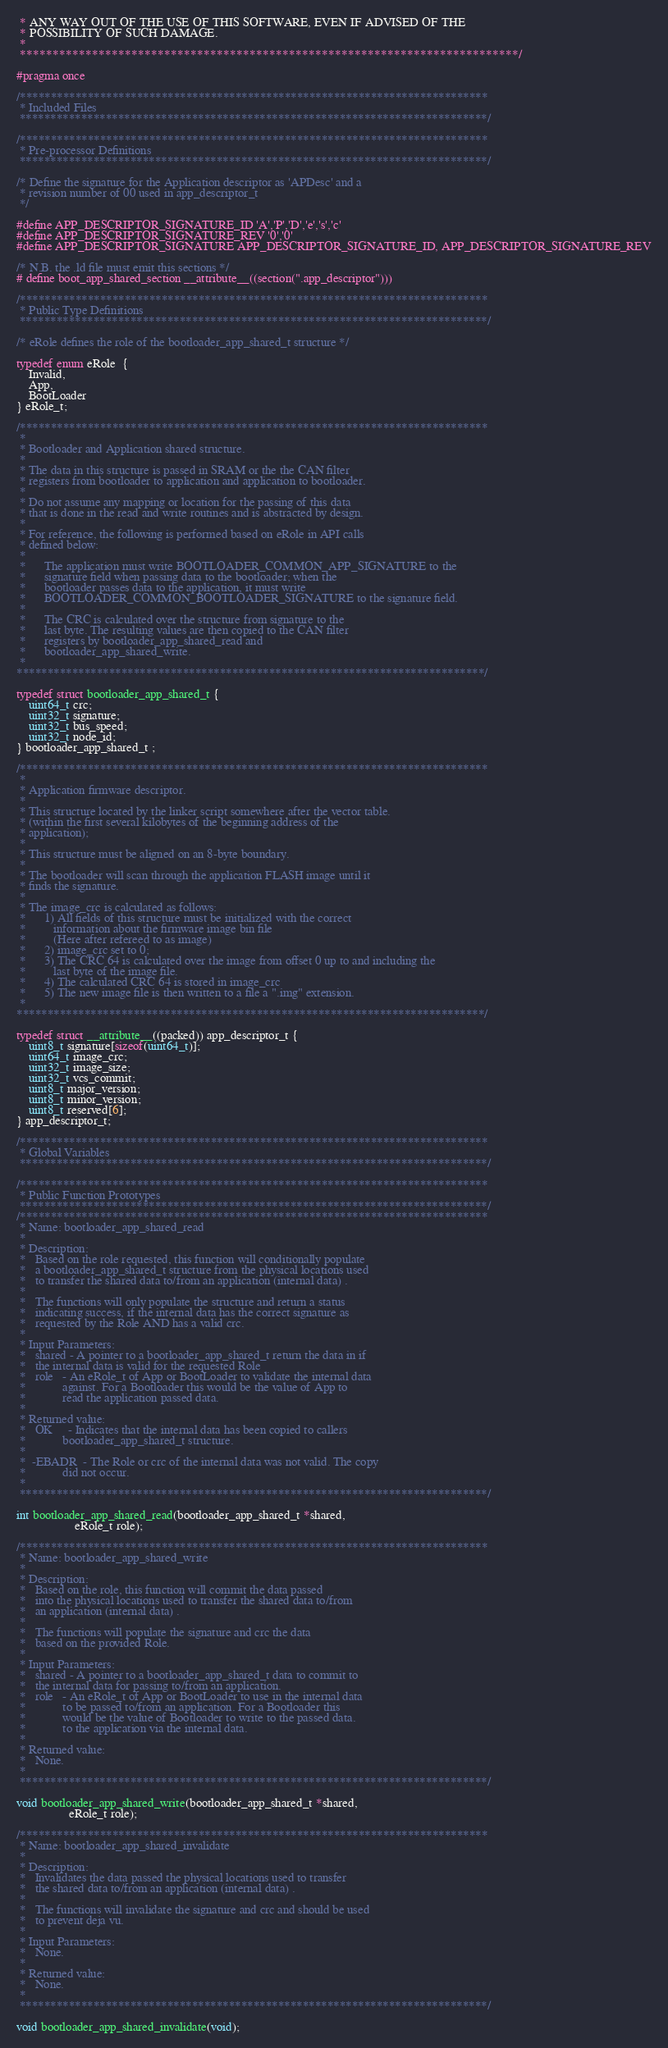<code> <loc_0><loc_0><loc_500><loc_500><_C_> * ANY WAY OUT OF THE USE OF THIS SOFTWARE, EVEN IF ADVISED OF THE
 * POSSIBILITY OF SUCH DAMAGE.
 *
 ****************************************************************************/

#pragma once

/****************************************************************************
 * Included Files
 ****************************************************************************/

/****************************************************************************
 * Pre-processor Definitions
 ****************************************************************************/

/* Define the signature for the Application descriptor as 'APDesc' and a
 * revision number of 00 used in app_descriptor_t
 */

#define APP_DESCRIPTOR_SIGNATURE_ID 'A','P','D','e','s','c'
#define APP_DESCRIPTOR_SIGNATURE_REV '0','0'
#define APP_DESCRIPTOR_SIGNATURE APP_DESCRIPTOR_SIGNATURE_ID, APP_DESCRIPTOR_SIGNATURE_REV

/* N.B. the .ld file must emit this sections */
# define boot_app_shared_section __attribute__((section(".app_descriptor")))

/****************************************************************************
 * Public Type Definitions
 ****************************************************************************/

/* eRole defines the role of the bootloader_app_shared_t structure */

typedef enum eRole  {
	Invalid,
	App,
	BootLoader
} eRole_t;

/****************************************************************************
 *
 * Bootloader and Application shared structure.
 *
 * The data in this structure is passed in SRAM or the the CAN filter
 * registers from bootloader to application and application to bootloader.
 *
 * Do not assume any mapping or location for the passing of this data
 * that is done in the read and write routines and is abstracted by design.
 *
 * For reference, the following is performed based on eRole in API calls
 * defined below:
 *
 *      The application must write BOOTLOADER_COMMON_APP_SIGNATURE to the
 *      signature field when passing data to the bootloader; when the
 *      bootloader passes data to the application, it must write
 *      BOOTLOADER_COMMON_BOOTLOADER_SIGNATURE to the signature field.
 *
 *      The CRC is calculated over the structure from signature to the
 *      last byte. The resulting values are then copied to the CAN filter
 *      registers by bootloader_app_shared_read and
 *      bootloader_app_shared_write.
 *
****************************************************************************/

typedef struct bootloader_app_shared_t {
	uint64_t crc;
	uint32_t signature;
	uint32_t bus_speed;
	uint32_t node_id;
} bootloader_app_shared_t ;

/****************************************************************************
 *
 * Application firmware descriptor.
 *
 * This structure located by the linker script somewhere after the vector table.
 * (within the first several kilobytes of the beginning address of the
 * application);
 *
 * This structure must be aligned on an 8-byte boundary.
 *
 * The bootloader will scan through the application FLASH image until it
 * finds the signature.
 *
 * The image_crc is calculated as follows:
 *      1) All fields of this structure must be initialized with the correct
 *         information about the firmware image bin file
 *         (Here after refereed to as image)
 *      2) image_crc set to 0;
 *      3) The CRC 64 is calculated over the image from offset 0 up to and including the
 *         last byte of the image file.
 *      4) The calculated CRC 64 is stored in image_crc
 *      5) The new image file is then written to a file a ".img" extension.
 *
****************************************************************************/

typedef struct __attribute__((packed)) app_descriptor_t {
	uint8_t signature[sizeof(uint64_t)];
	uint64_t image_crc;
	uint32_t image_size;
	uint32_t vcs_commit;
	uint8_t major_version;
	uint8_t minor_version;
	uint8_t reserved[6];
} app_descriptor_t;

/****************************************************************************
 * Global Variables
 ****************************************************************************/

/****************************************************************************
 * Public Function Prototypes
 ****************************************************************************/
/****************************************************************************
 * Name: bootloader_app_shared_read
 *
 * Description:
 *   Based on the role requested, this function will conditionally populate
 *   a bootloader_app_shared_t structure from the physical locations used
 *   to transfer the shared data to/from an application (internal data) .
 *
 *   The functions will only populate the structure and return a status
 *   indicating success, if the internal data has the correct signature as
 *   requested by the Role AND has a valid crc.
 *
 * Input Parameters:
 *   shared - A pointer to a bootloader_app_shared_t return the data in if
 *   the internal data is valid for the requested Role
 *   role   - An eRole_t of App or BootLoader to validate the internal data
 *            against. For a Bootloader this would be the value of App to
 *            read the application passed data.
 *
 * Returned value:
 *   OK     - Indicates that the internal data has been copied to callers
 *            bootloader_app_shared_t structure.
 *
 *  -EBADR  - The Role or crc of the internal data was not valid. The copy
 *            did not occur.
 *
 ****************************************************************************/

int bootloader_app_shared_read(bootloader_app_shared_t *shared,
			       eRole_t role);

/****************************************************************************
 * Name: bootloader_app_shared_write
 *
 * Description:
 *   Based on the role, this function will commit the data passed
 *   into the physical locations used to transfer the shared data to/from
 *   an application (internal data) .
 *
 *   The functions will populate the signature and crc the data
 *   based on the provided Role.
 *
 * Input Parameters:
 *   shared - A pointer to a bootloader_app_shared_t data to commit to
 *   the internal data for passing to/from an application.
 *   role   - An eRole_t of App or BootLoader to use in the internal data
 *            to be passed to/from an application. For a Bootloader this
 *            would be the value of Bootloader to write to the passed data.
 *            to the application via the internal data.
 *
 * Returned value:
 *   None.
 *
 ****************************************************************************/

void bootloader_app_shared_write(bootloader_app_shared_t *shared,
				 eRole_t role);

/****************************************************************************
 * Name: bootloader_app_shared_invalidate
 *
 * Description:
 *   Invalidates the data passed the physical locations used to transfer
 *   the shared data to/from an application (internal data) .
 *
 *   The functions will invalidate the signature and crc and should be used
 *   to prevent deja vu.
 *
 * Input Parameters:
 *   None.
 *
 * Returned value:
 *   None.
 *
 ****************************************************************************/

void bootloader_app_shared_invalidate(void);
</code> 